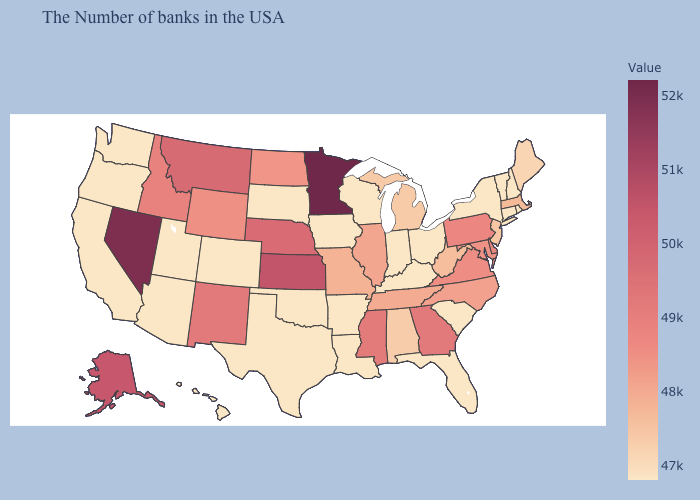Which states have the highest value in the USA?
Concise answer only. Minnesota. Does Vermont have the lowest value in the USA?
Answer briefly. Yes. Which states hav the highest value in the West?
Answer briefly. Nevada. Among the states that border New Hampshire , which have the highest value?
Give a very brief answer. Massachusetts. Does Vermont have the lowest value in the Northeast?
Be succinct. Yes. Among the states that border Montana , which have the highest value?
Give a very brief answer. Idaho. Among the states that border Massachusetts , which have the highest value?
Quick response, please. Rhode Island, New Hampshire, Vermont, Connecticut, New York. Among the states that border Tennessee , does Arkansas have the lowest value?
Be succinct. Yes. Does Nevada have the highest value in the West?
Concise answer only. Yes. Does Ohio have the highest value in the MidWest?
Short answer required. No. 